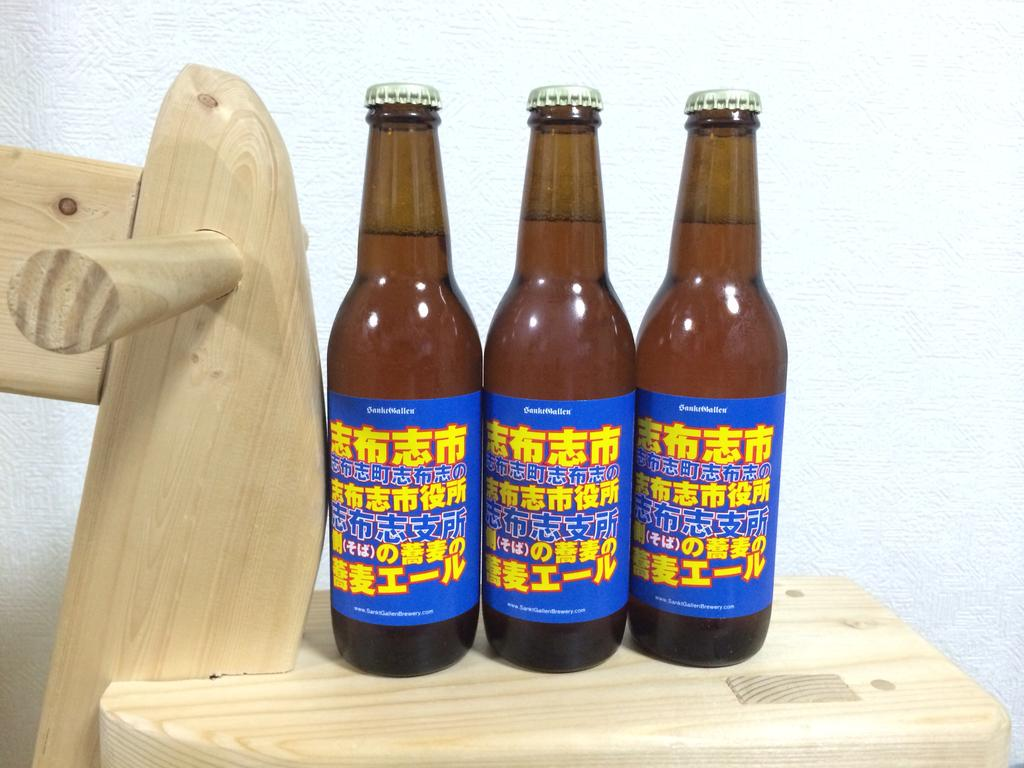How many bottles are visible in the image? There are three bottles in the image. What feature makes the bottles stand out in the image? The bottles are highlighted in the image. What material are the bottles made of? The bottles are made of wood. Are there any decorations or markings on the bottles? Yes, the bottles have stickers on them. What is inside the bottles? The bottles are filled with liquids. What is the purpose of the snail in the image? There is no snail present in the image. What form does the liquid inside the bottles take? The provided facts do not specify the form of the liquid inside the bottles, only that they are filled with liquids. 